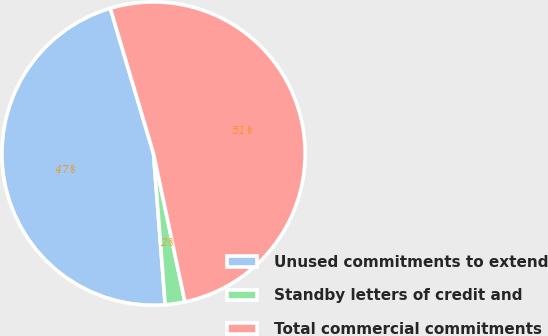<chart> <loc_0><loc_0><loc_500><loc_500><pie_chart><fcel>Unused commitments to extend<fcel>Standby letters of credit and<fcel>Total commercial commitments<nl><fcel>46.62%<fcel>2.1%<fcel>51.28%<nl></chart> 